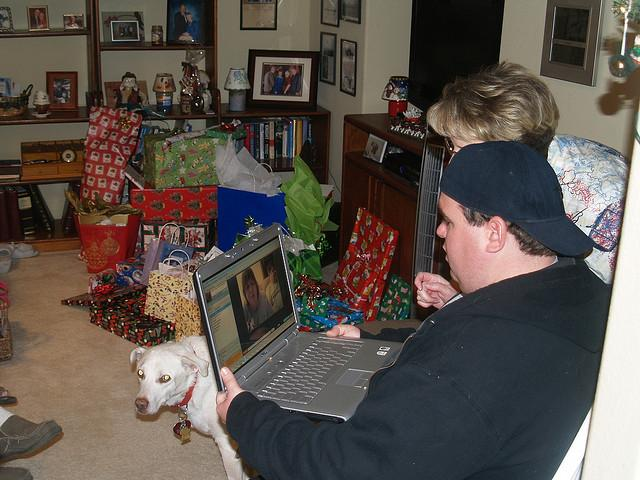What came in all those colored boxes? presents 